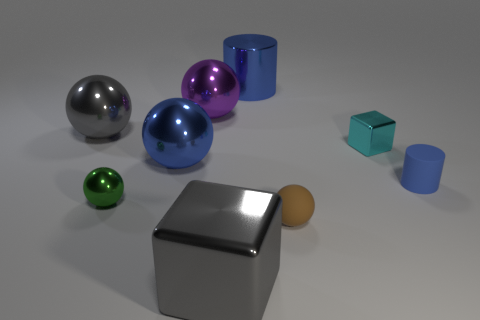There is a large thing that is the same color as the big metal cube; what is its shape?
Offer a terse response. Sphere. Are there fewer purple shiny objects in front of the large gray shiny cube than small cyan metal blocks?
Keep it short and to the point. Yes. Is the number of brown things left of the green ball greater than the number of big purple spheres on the right side of the small blue rubber cylinder?
Your response must be concise. No. Are there any other things that are the same color as the large metal block?
Your answer should be compact. Yes. What material is the large gray object left of the tiny metal ball?
Your answer should be compact. Metal. Is the rubber cylinder the same size as the brown matte ball?
Ensure brevity in your answer.  Yes. What number of other things are the same size as the purple metallic object?
Give a very brief answer. 4. Is the color of the tiny rubber cylinder the same as the metallic cylinder?
Keep it short and to the point. Yes. What is the shape of the big gray object behind the gray object in front of the gray metal object behind the big shiny block?
Your answer should be very brief. Sphere. What number of objects are either small metallic objects to the left of the small brown ball or shiny objects in front of the small brown thing?
Give a very brief answer. 2. 